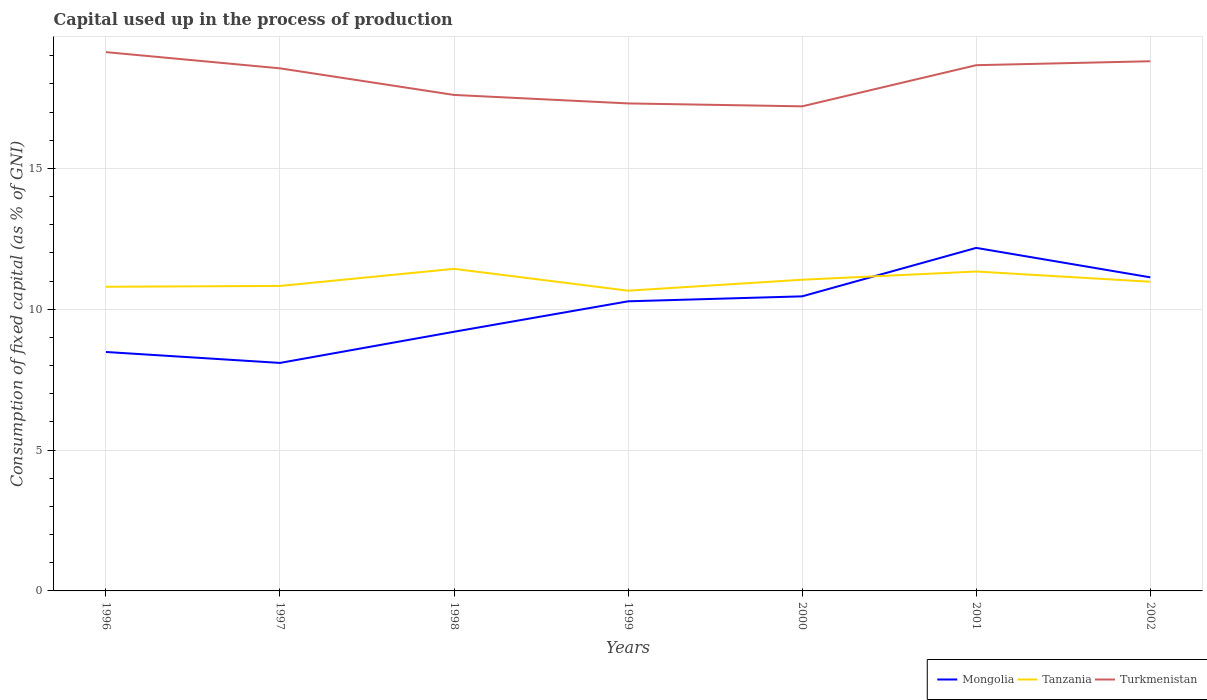How many different coloured lines are there?
Ensure brevity in your answer.  3. Is the number of lines equal to the number of legend labels?
Offer a very short reply. Yes. Across all years, what is the maximum capital used up in the process of production in Turkmenistan?
Offer a very short reply. 17.2. In which year was the capital used up in the process of production in Tanzania maximum?
Offer a very short reply. 1999. What is the total capital used up in the process of production in Mongolia in the graph?
Ensure brevity in your answer.  -1.9. What is the difference between the highest and the second highest capital used up in the process of production in Turkmenistan?
Make the answer very short. 1.92. What is the difference between the highest and the lowest capital used up in the process of production in Tanzania?
Your response must be concise. 3. Is the capital used up in the process of production in Mongolia strictly greater than the capital used up in the process of production in Turkmenistan over the years?
Give a very brief answer. Yes. How many years are there in the graph?
Give a very brief answer. 7. Does the graph contain any zero values?
Your answer should be compact. No. Does the graph contain grids?
Make the answer very short. Yes. How are the legend labels stacked?
Make the answer very short. Horizontal. What is the title of the graph?
Your answer should be very brief. Capital used up in the process of production. Does "Lithuania" appear as one of the legend labels in the graph?
Give a very brief answer. No. What is the label or title of the Y-axis?
Offer a terse response. Consumption of fixed capital (as % of GNI). What is the Consumption of fixed capital (as % of GNI) of Mongolia in 1996?
Your answer should be very brief. 8.48. What is the Consumption of fixed capital (as % of GNI) in Tanzania in 1996?
Make the answer very short. 10.8. What is the Consumption of fixed capital (as % of GNI) in Turkmenistan in 1996?
Your response must be concise. 19.13. What is the Consumption of fixed capital (as % of GNI) of Mongolia in 1997?
Keep it short and to the point. 8.09. What is the Consumption of fixed capital (as % of GNI) in Tanzania in 1997?
Keep it short and to the point. 10.83. What is the Consumption of fixed capital (as % of GNI) in Turkmenistan in 1997?
Offer a terse response. 18.55. What is the Consumption of fixed capital (as % of GNI) in Mongolia in 1998?
Provide a short and direct response. 9.2. What is the Consumption of fixed capital (as % of GNI) in Tanzania in 1998?
Make the answer very short. 11.43. What is the Consumption of fixed capital (as % of GNI) in Turkmenistan in 1998?
Offer a terse response. 17.61. What is the Consumption of fixed capital (as % of GNI) in Mongolia in 1999?
Ensure brevity in your answer.  10.28. What is the Consumption of fixed capital (as % of GNI) in Tanzania in 1999?
Offer a very short reply. 10.66. What is the Consumption of fixed capital (as % of GNI) of Turkmenistan in 1999?
Your answer should be very brief. 17.31. What is the Consumption of fixed capital (as % of GNI) in Mongolia in 2000?
Your answer should be compact. 10.46. What is the Consumption of fixed capital (as % of GNI) in Tanzania in 2000?
Provide a succinct answer. 11.05. What is the Consumption of fixed capital (as % of GNI) in Turkmenistan in 2000?
Offer a terse response. 17.2. What is the Consumption of fixed capital (as % of GNI) in Mongolia in 2001?
Your answer should be compact. 12.18. What is the Consumption of fixed capital (as % of GNI) of Tanzania in 2001?
Ensure brevity in your answer.  11.34. What is the Consumption of fixed capital (as % of GNI) in Turkmenistan in 2001?
Your response must be concise. 18.66. What is the Consumption of fixed capital (as % of GNI) of Mongolia in 2002?
Provide a succinct answer. 11.13. What is the Consumption of fixed capital (as % of GNI) in Tanzania in 2002?
Your answer should be very brief. 10.98. What is the Consumption of fixed capital (as % of GNI) of Turkmenistan in 2002?
Provide a succinct answer. 18.8. Across all years, what is the maximum Consumption of fixed capital (as % of GNI) of Mongolia?
Your answer should be very brief. 12.18. Across all years, what is the maximum Consumption of fixed capital (as % of GNI) of Tanzania?
Provide a short and direct response. 11.43. Across all years, what is the maximum Consumption of fixed capital (as % of GNI) in Turkmenistan?
Keep it short and to the point. 19.13. Across all years, what is the minimum Consumption of fixed capital (as % of GNI) in Mongolia?
Your answer should be compact. 8.09. Across all years, what is the minimum Consumption of fixed capital (as % of GNI) of Tanzania?
Your answer should be very brief. 10.66. Across all years, what is the minimum Consumption of fixed capital (as % of GNI) of Turkmenistan?
Provide a short and direct response. 17.2. What is the total Consumption of fixed capital (as % of GNI) in Mongolia in the graph?
Provide a succinct answer. 69.83. What is the total Consumption of fixed capital (as % of GNI) of Tanzania in the graph?
Give a very brief answer. 77.08. What is the total Consumption of fixed capital (as % of GNI) in Turkmenistan in the graph?
Your response must be concise. 127.26. What is the difference between the Consumption of fixed capital (as % of GNI) in Mongolia in 1996 and that in 1997?
Offer a terse response. 0.39. What is the difference between the Consumption of fixed capital (as % of GNI) in Tanzania in 1996 and that in 1997?
Your answer should be very brief. -0.03. What is the difference between the Consumption of fixed capital (as % of GNI) in Turkmenistan in 1996 and that in 1997?
Your answer should be very brief. 0.58. What is the difference between the Consumption of fixed capital (as % of GNI) of Mongolia in 1996 and that in 1998?
Offer a terse response. -0.72. What is the difference between the Consumption of fixed capital (as % of GNI) in Tanzania in 1996 and that in 1998?
Offer a terse response. -0.64. What is the difference between the Consumption of fixed capital (as % of GNI) in Turkmenistan in 1996 and that in 1998?
Give a very brief answer. 1.52. What is the difference between the Consumption of fixed capital (as % of GNI) of Mongolia in 1996 and that in 1999?
Offer a very short reply. -1.8. What is the difference between the Consumption of fixed capital (as % of GNI) in Tanzania in 1996 and that in 1999?
Provide a short and direct response. 0.14. What is the difference between the Consumption of fixed capital (as % of GNI) of Turkmenistan in 1996 and that in 1999?
Offer a very short reply. 1.82. What is the difference between the Consumption of fixed capital (as % of GNI) in Mongolia in 1996 and that in 2000?
Provide a succinct answer. -1.98. What is the difference between the Consumption of fixed capital (as % of GNI) in Tanzania in 1996 and that in 2000?
Your answer should be very brief. -0.25. What is the difference between the Consumption of fixed capital (as % of GNI) of Turkmenistan in 1996 and that in 2000?
Make the answer very short. 1.92. What is the difference between the Consumption of fixed capital (as % of GNI) of Mongolia in 1996 and that in 2001?
Make the answer very short. -3.7. What is the difference between the Consumption of fixed capital (as % of GNI) in Tanzania in 1996 and that in 2001?
Keep it short and to the point. -0.54. What is the difference between the Consumption of fixed capital (as % of GNI) in Turkmenistan in 1996 and that in 2001?
Provide a succinct answer. 0.46. What is the difference between the Consumption of fixed capital (as % of GNI) of Mongolia in 1996 and that in 2002?
Provide a succinct answer. -2.65. What is the difference between the Consumption of fixed capital (as % of GNI) in Tanzania in 1996 and that in 2002?
Make the answer very short. -0.18. What is the difference between the Consumption of fixed capital (as % of GNI) in Turkmenistan in 1996 and that in 2002?
Keep it short and to the point. 0.32. What is the difference between the Consumption of fixed capital (as % of GNI) in Mongolia in 1997 and that in 1998?
Keep it short and to the point. -1.11. What is the difference between the Consumption of fixed capital (as % of GNI) in Tanzania in 1997 and that in 1998?
Keep it short and to the point. -0.61. What is the difference between the Consumption of fixed capital (as % of GNI) of Turkmenistan in 1997 and that in 1998?
Offer a very short reply. 0.94. What is the difference between the Consumption of fixed capital (as % of GNI) of Mongolia in 1997 and that in 1999?
Provide a short and direct response. -2.19. What is the difference between the Consumption of fixed capital (as % of GNI) of Tanzania in 1997 and that in 1999?
Give a very brief answer. 0.17. What is the difference between the Consumption of fixed capital (as % of GNI) of Turkmenistan in 1997 and that in 1999?
Your answer should be very brief. 1.25. What is the difference between the Consumption of fixed capital (as % of GNI) of Mongolia in 1997 and that in 2000?
Make the answer very short. -2.36. What is the difference between the Consumption of fixed capital (as % of GNI) of Tanzania in 1997 and that in 2000?
Provide a short and direct response. -0.22. What is the difference between the Consumption of fixed capital (as % of GNI) in Turkmenistan in 1997 and that in 2000?
Your response must be concise. 1.35. What is the difference between the Consumption of fixed capital (as % of GNI) of Mongolia in 1997 and that in 2001?
Ensure brevity in your answer.  -4.08. What is the difference between the Consumption of fixed capital (as % of GNI) in Tanzania in 1997 and that in 2001?
Ensure brevity in your answer.  -0.51. What is the difference between the Consumption of fixed capital (as % of GNI) of Turkmenistan in 1997 and that in 2001?
Your response must be concise. -0.11. What is the difference between the Consumption of fixed capital (as % of GNI) of Mongolia in 1997 and that in 2002?
Give a very brief answer. -3.04. What is the difference between the Consumption of fixed capital (as % of GNI) of Tanzania in 1997 and that in 2002?
Offer a very short reply. -0.15. What is the difference between the Consumption of fixed capital (as % of GNI) in Turkmenistan in 1997 and that in 2002?
Keep it short and to the point. -0.25. What is the difference between the Consumption of fixed capital (as % of GNI) in Mongolia in 1998 and that in 1999?
Make the answer very short. -1.08. What is the difference between the Consumption of fixed capital (as % of GNI) of Tanzania in 1998 and that in 1999?
Provide a short and direct response. 0.78. What is the difference between the Consumption of fixed capital (as % of GNI) of Turkmenistan in 1998 and that in 1999?
Provide a succinct answer. 0.3. What is the difference between the Consumption of fixed capital (as % of GNI) of Mongolia in 1998 and that in 2000?
Your answer should be compact. -1.26. What is the difference between the Consumption of fixed capital (as % of GNI) of Tanzania in 1998 and that in 2000?
Your answer should be very brief. 0.39. What is the difference between the Consumption of fixed capital (as % of GNI) in Turkmenistan in 1998 and that in 2000?
Provide a succinct answer. 0.4. What is the difference between the Consumption of fixed capital (as % of GNI) of Mongolia in 1998 and that in 2001?
Ensure brevity in your answer.  -2.98. What is the difference between the Consumption of fixed capital (as % of GNI) of Tanzania in 1998 and that in 2001?
Ensure brevity in your answer.  0.1. What is the difference between the Consumption of fixed capital (as % of GNI) in Turkmenistan in 1998 and that in 2001?
Offer a terse response. -1.06. What is the difference between the Consumption of fixed capital (as % of GNI) of Mongolia in 1998 and that in 2002?
Keep it short and to the point. -1.93. What is the difference between the Consumption of fixed capital (as % of GNI) of Tanzania in 1998 and that in 2002?
Your response must be concise. 0.46. What is the difference between the Consumption of fixed capital (as % of GNI) in Turkmenistan in 1998 and that in 2002?
Provide a short and direct response. -1.2. What is the difference between the Consumption of fixed capital (as % of GNI) of Mongolia in 1999 and that in 2000?
Provide a short and direct response. -0.18. What is the difference between the Consumption of fixed capital (as % of GNI) in Tanzania in 1999 and that in 2000?
Offer a very short reply. -0.39. What is the difference between the Consumption of fixed capital (as % of GNI) in Turkmenistan in 1999 and that in 2000?
Your answer should be very brief. 0.1. What is the difference between the Consumption of fixed capital (as % of GNI) of Mongolia in 1999 and that in 2001?
Your response must be concise. -1.9. What is the difference between the Consumption of fixed capital (as % of GNI) in Tanzania in 1999 and that in 2001?
Give a very brief answer. -0.68. What is the difference between the Consumption of fixed capital (as % of GNI) in Turkmenistan in 1999 and that in 2001?
Your answer should be very brief. -1.36. What is the difference between the Consumption of fixed capital (as % of GNI) of Mongolia in 1999 and that in 2002?
Make the answer very short. -0.85. What is the difference between the Consumption of fixed capital (as % of GNI) of Tanzania in 1999 and that in 2002?
Keep it short and to the point. -0.32. What is the difference between the Consumption of fixed capital (as % of GNI) in Turkmenistan in 1999 and that in 2002?
Give a very brief answer. -1.5. What is the difference between the Consumption of fixed capital (as % of GNI) in Mongolia in 2000 and that in 2001?
Offer a terse response. -1.72. What is the difference between the Consumption of fixed capital (as % of GNI) in Tanzania in 2000 and that in 2001?
Keep it short and to the point. -0.29. What is the difference between the Consumption of fixed capital (as % of GNI) of Turkmenistan in 2000 and that in 2001?
Your response must be concise. -1.46. What is the difference between the Consumption of fixed capital (as % of GNI) in Mongolia in 2000 and that in 2002?
Provide a short and direct response. -0.68. What is the difference between the Consumption of fixed capital (as % of GNI) of Tanzania in 2000 and that in 2002?
Offer a very short reply. 0.07. What is the difference between the Consumption of fixed capital (as % of GNI) in Turkmenistan in 2000 and that in 2002?
Provide a short and direct response. -1.6. What is the difference between the Consumption of fixed capital (as % of GNI) of Mongolia in 2001 and that in 2002?
Make the answer very short. 1.04. What is the difference between the Consumption of fixed capital (as % of GNI) in Tanzania in 2001 and that in 2002?
Give a very brief answer. 0.36. What is the difference between the Consumption of fixed capital (as % of GNI) of Turkmenistan in 2001 and that in 2002?
Provide a succinct answer. -0.14. What is the difference between the Consumption of fixed capital (as % of GNI) of Mongolia in 1996 and the Consumption of fixed capital (as % of GNI) of Tanzania in 1997?
Give a very brief answer. -2.34. What is the difference between the Consumption of fixed capital (as % of GNI) in Mongolia in 1996 and the Consumption of fixed capital (as % of GNI) in Turkmenistan in 1997?
Provide a short and direct response. -10.07. What is the difference between the Consumption of fixed capital (as % of GNI) in Tanzania in 1996 and the Consumption of fixed capital (as % of GNI) in Turkmenistan in 1997?
Offer a terse response. -7.75. What is the difference between the Consumption of fixed capital (as % of GNI) of Mongolia in 1996 and the Consumption of fixed capital (as % of GNI) of Tanzania in 1998?
Your response must be concise. -2.95. What is the difference between the Consumption of fixed capital (as % of GNI) of Mongolia in 1996 and the Consumption of fixed capital (as % of GNI) of Turkmenistan in 1998?
Offer a terse response. -9.13. What is the difference between the Consumption of fixed capital (as % of GNI) of Tanzania in 1996 and the Consumption of fixed capital (as % of GNI) of Turkmenistan in 1998?
Offer a very short reply. -6.81. What is the difference between the Consumption of fixed capital (as % of GNI) in Mongolia in 1996 and the Consumption of fixed capital (as % of GNI) in Tanzania in 1999?
Provide a succinct answer. -2.18. What is the difference between the Consumption of fixed capital (as % of GNI) of Mongolia in 1996 and the Consumption of fixed capital (as % of GNI) of Turkmenistan in 1999?
Offer a very short reply. -8.82. What is the difference between the Consumption of fixed capital (as % of GNI) of Tanzania in 1996 and the Consumption of fixed capital (as % of GNI) of Turkmenistan in 1999?
Keep it short and to the point. -6.51. What is the difference between the Consumption of fixed capital (as % of GNI) of Mongolia in 1996 and the Consumption of fixed capital (as % of GNI) of Tanzania in 2000?
Offer a terse response. -2.56. What is the difference between the Consumption of fixed capital (as % of GNI) in Mongolia in 1996 and the Consumption of fixed capital (as % of GNI) in Turkmenistan in 2000?
Your answer should be compact. -8.72. What is the difference between the Consumption of fixed capital (as % of GNI) in Tanzania in 1996 and the Consumption of fixed capital (as % of GNI) in Turkmenistan in 2000?
Your response must be concise. -6.41. What is the difference between the Consumption of fixed capital (as % of GNI) in Mongolia in 1996 and the Consumption of fixed capital (as % of GNI) in Tanzania in 2001?
Provide a succinct answer. -2.86. What is the difference between the Consumption of fixed capital (as % of GNI) in Mongolia in 1996 and the Consumption of fixed capital (as % of GNI) in Turkmenistan in 2001?
Ensure brevity in your answer.  -10.18. What is the difference between the Consumption of fixed capital (as % of GNI) of Tanzania in 1996 and the Consumption of fixed capital (as % of GNI) of Turkmenistan in 2001?
Ensure brevity in your answer.  -7.87. What is the difference between the Consumption of fixed capital (as % of GNI) of Mongolia in 1996 and the Consumption of fixed capital (as % of GNI) of Tanzania in 2002?
Your response must be concise. -2.49. What is the difference between the Consumption of fixed capital (as % of GNI) in Mongolia in 1996 and the Consumption of fixed capital (as % of GNI) in Turkmenistan in 2002?
Keep it short and to the point. -10.32. What is the difference between the Consumption of fixed capital (as % of GNI) in Tanzania in 1996 and the Consumption of fixed capital (as % of GNI) in Turkmenistan in 2002?
Provide a short and direct response. -8.01. What is the difference between the Consumption of fixed capital (as % of GNI) in Mongolia in 1997 and the Consumption of fixed capital (as % of GNI) in Tanzania in 1998?
Ensure brevity in your answer.  -3.34. What is the difference between the Consumption of fixed capital (as % of GNI) of Mongolia in 1997 and the Consumption of fixed capital (as % of GNI) of Turkmenistan in 1998?
Provide a succinct answer. -9.51. What is the difference between the Consumption of fixed capital (as % of GNI) in Tanzania in 1997 and the Consumption of fixed capital (as % of GNI) in Turkmenistan in 1998?
Give a very brief answer. -6.78. What is the difference between the Consumption of fixed capital (as % of GNI) of Mongolia in 1997 and the Consumption of fixed capital (as % of GNI) of Tanzania in 1999?
Offer a terse response. -2.56. What is the difference between the Consumption of fixed capital (as % of GNI) in Mongolia in 1997 and the Consumption of fixed capital (as % of GNI) in Turkmenistan in 1999?
Make the answer very short. -9.21. What is the difference between the Consumption of fixed capital (as % of GNI) of Tanzania in 1997 and the Consumption of fixed capital (as % of GNI) of Turkmenistan in 1999?
Make the answer very short. -6.48. What is the difference between the Consumption of fixed capital (as % of GNI) of Mongolia in 1997 and the Consumption of fixed capital (as % of GNI) of Tanzania in 2000?
Give a very brief answer. -2.95. What is the difference between the Consumption of fixed capital (as % of GNI) of Mongolia in 1997 and the Consumption of fixed capital (as % of GNI) of Turkmenistan in 2000?
Provide a succinct answer. -9.11. What is the difference between the Consumption of fixed capital (as % of GNI) of Tanzania in 1997 and the Consumption of fixed capital (as % of GNI) of Turkmenistan in 2000?
Give a very brief answer. -6.38. What is the difference between the Consumption of fixed capital (as % of GNI) of Mongolia in 1997 and the Consumption of fixed capital (as % of GNI) of Tanzania in 2001?
Your answer should be compact. -3.25. What is the difference between the Consumption of fixed capital (as % of GNI) in Mongolia in 1997 and the Consumption of fixed capital (as % of GNI) in Turkmenistan in 2001?
Offer a terse response. -10.57. What is the difference between the Consumption of fixed capital (as % of GNI) in Tanzania in 1997 and the Consumption of fixed capital (as % of GNI) in Turkmenistan in 2001?
Your response must be concise. -7.84. What is the difference between the Consumption of fixed capital (as % of GNI) of Mongolia in 1997 and the Consumption of fixed capital (as % of GNI) of Tanzania in 2002?
Make the answer very short. -2.88. What is the difference between the Consumption of fixed capital (as % of GNI) in Mongolia in 1997 and the Consumption of fixed capital (as % of GNI) in Turkmenistan in 2002?
Offer a very short reply. -10.71. What is the difference between the Consumption of fixed capital (as % of GNI) of Tanzania in 1997 and the Consumption of fixed capital (as % of GNI) of Turkmenistan in 2002?
Provide a short and direct response. -7.98. What is the difference between the Consumption of fixed capital (as % of GNI) of Mongolia in 1998 and the Consumption of fixed capital (as % of GNI) of Tanzania in 1999?
Offer a terse response. -1.46. What is the difference between the Consumption of fixed capital (as % of GNI) in Mongolia in 1998 and the Consumption of fixed capital (as % of GNI) in Turkmenistan in 1999?
Give a very brief answer. -8.11. What is the difference between the Consumption of fixed capital (as % of GNI) in Tanzania in 1998 and the Consumption of fixed capital (as % of GNI) in Turkmenistan in 1999?
Offer a very short reply. -5.87. What is the difference between the Consumption of fixed capital (as % of GNI) in Mongolia in 1998 and the Consumption of fixed capital (as % of GNI) in Tanzania in 2000?
Your answer should be compact. -1.85. What is the difference between the Consumption of fixed capital (as % of GNI) of Mongolia in 1998 and the Consumption of fixed capital (as % of GNI) of Turkmenistan in 2000?
Your answer should be very brief. -8. What is the difference between the Consumption of fixed capital (as % of GNI) in Tanzania in 1998 and the Consumption of fixed capital (as % of GNI) in Turkmenistan in 2000?
Your answer should be compact. -5.77. What is the difference between the Consumption of fixed capital (as % of GNI) in Mongolia in 1998 and the Consumption of fixed capital (as % of GNI) in Tanzania in 2001?
Your answer should be compact. -2.14. What is the difference between the Consumption of fixed capital (as % of GNI) in Mongolia in 1998 and the Consumption of fixed capital (as % of GNI) in Turkmenistan in 2001?
Provide a succinct answer. -9.46. What is the difference between the Consumption of fixed capital (as % of GNI) in Tanzania in 1998 and the Consumption of fixed capital (as % of GNI) in Turkmenistan in 2001?
Your answer should be compact. -7.23. What is the difference between the Consumption of fixed capital (as % of GNI) in Mongolia in 1998 and the Consumption of fixed capital (as % of GNI) in Tanzania in 2002?
Your response must be concise. -1.77. What is the difference between the Consumption of fixed capital (as % of GNI) of Mongolia in 1998 and the Consumption of fixed capital (as % of GNI) of Turkmenistan in 2002?
Give a very brief answer. -9.6. What is the difference between the Consumption of fixed capital (as % of GNI) of Tanzania in 1998 and the Consumption of fixed capital (as % of GNI) of Turkmenistan in 2002?
Provide a succinct answer. -7.37. What is the difference between the Consumption of fixed capital (as % of GNI) of Mongolia in 1999 and the Consumption of fixed capital (as % of GNI) of Tanzania in 2000?
Offer a very short reply. -0.77. What is the difference between the Consumption of fixed capital (as % of GNI) of Mongolia in 1999 and the Consumption of fixed capital (as % of GNI) of Turkmenistan in 2000?
Give a very brief answer. -6.92. What is the difference between the Consumption of fixed capital (as % of GNI) of Tanzania in 1999 and the Consumption of fixed capital (as % of GNI) of Turkmenistan in 2000?
Provide a short and direct response. -6.54. What is the difference between the Consumption of fixed capital (as % of GNI) of Mongolia in 1999 and the Consumption of fixed capital (as % of GNI) of Tanzania in 2001?
Offer a terse response. -1.06. What is the difference between the Consumption of fixed capital (as % of GNI) in Mongolia in 1999 and the Consumption of fixed capital (as % of GNI) in Turkmenistan in 2001?
Provide a short and direct response. -8.38. What is the difference between the Consumption of fixed capital (as % of GNI) of Tanzania in 1999 and the Consumption of fixed capital (as % of GNI) of Turkmenistan in 2001?
Provide a short and direct response. -8. What is the difference between the Consumption of fixed capital (as % of GNI) of Mongolia in 1999 and the Consumption of fixed capital (as % of GNI) of Tanzania in 2002?
Keep it short and to the point. -0.69. What is the difference between the Consumption of fixed capital (as % of GNI) in Mongolia in 1999 and the Consumption of fixed capital (as % of GNI) in Turkmenistan in 2002?
Offer a terse response. -8.52. What is the difference between the Consumption of fixed capital (as % of GNI) of Tanzania in 1999 and the Consumption of fixed capital (as % of GNI) of Turkmenistan in 2002?
Make the answer very short. -8.14. What is the difference between the Consumption of fixed capital (as % of GNI) of Mongolia in 2000 and the Consumption of fixed capital (as % of GNI) of Tanzania in 2001?
Your answer should be very brief. -0.88. What is the difference between the Consumption of fixed capital (as % of GNI) of Mongolia in 2000 and the Consumption of fixed capital (as % of GNI) of Turkmenistan in 2001?
Your response must be concise. -8.21. What is the difference between the Consumption of fixed capital (as % of GNI) in Tanzania in 2000 and the Consumption of fixed capital (as % of GNI) in Turkmenistan in 2001?
Provide a short and direct response. -7.62. What is the difference between the Consumption of fixed capital (as % of GNI) in Mongolia in 2000 and the Consumption of fixed capital (as % of GNI) in Tanzania in 2002?
Your answer should be very brief. -0.52. What is the difference between the Consumption of fixed capital (as % of GNI) in Mongolia in 2000 and the Consumption of fixed capital (as % of GNI) in Turkmenistan in 2002?
Ensure brevity in your answer.  -8.35. What is the difference between the Consumption of fixed capital (as % of GNI) of Tanzania in 2000 and the Consumption of fixed capital (as % of GNI) of Turkmenistan in 2002?
Provide a short and direct response. -7.76. What is the difference between the Consumption of fixed capital (as % of GNI) in Mongolia in 2001 and the Consumption of fixed capital (as % of GNI) in Tanzania in 2002?
Your answer should be very brief. 1.2. What is the difference between the Consumption of fixed capital (as % of GNI) of Mongolia in 2001 and the Consumption of fixed capital (as % of GNI) of Turkmenistan in 2002?
Provide a short and direct response. -6.63. What is the difference between the Consumption of fixed capital (as % of GNI) of Tanzania in 2001 and the Consumption of fixed capital (as % of GNI) of Turkmenistan in 2002?
Ensure brevity in your answer.  -7.46. What is the average Consumption of fixed capital (as % of GNI) of Mongolia per year?
Offer a very short reply. 9.98. What is the average Consumption of fixed capital (as % of GNI) in Tanzania per year?
Provide a short and direct response. 11.01. What is the average Consumption of fixed capital (as % of GNI) in Turkmenistan per year?
Your response must be concise. 18.18. In the year 1996, what is the difference between the Consumption of fixed capital (as % of GNI) of Mongolia and Consumption of fixed capital (as % of GNI) of Tanzania?
Your response must be concise. -2.32. In the year 1996, what is the difference between the Consumption of fixed capital (as % of GNI) of Mongolia and Consumption of fixed capital (as % of GNI) of Turkmenistan?
Provide a succinct answer. -10.65. In the year 1996, what is the difference between the Consumption of fixed capital (as % of GNI) in Tanzania and Consumption of fixed capital (as % of GNI) in Turkmenistan?
Your answer should be compact. -8.33. In the year 1997, what is the difference between the Consumption of fixed capital (as % of GNI) of Mongolia and Consumption of fixed capital (as % of GNI) of Tanzania?
Your response must be concise. -2.73. In the year 1997, what is the difference between the Consumption of fixed capital (as % of GNI) of Mongolia and Consumption of fixed capital (as % of GNI) of Turkmenistan?
Keep it short and to the point. -10.46. In the year 1997, what is the difference between the Consumption of fixed capital (as % of GNI) in Tanzania and Consumption of fixed capital (as % of GNI) in Turkmenistan?
Offer a very short reply. -7.72. In the year 1998, what is the difference between the Consumption of fixed capital (as % of GNI) of Mongolia and Consumption of fixed capital (as % of GNI) of Tanzania?
Ensure brevity in your answer.  -2.23. In the year 1998, what is the difference between the Consumption of fixed capital (as % of GNI) of Mongolia and Consumption of fixed capital (as % of GNI) of Turkmenistan?
Give a very brief answer. -8.41. In the year 1998, what is the difference between the Consumption of fixed capital (as % of GNI) of Tanzania and Consumption of fixed capital (as % of GNI) of Turkmenistan?
Your answer should be compact. -6.17. In the year 1999, what is the difference between the Consumption of fixed capital (as % of GNI) in Mongolia and Consumption of fixed capital (as % of GNI) in Tanzania?
Keep it short and to the point. -0.38. In the year 1999, what is the difference between the Consumption of fixed capital (as % of GNI) in Mongolia and Consumption of fixed capital (as % of GNI) in Turkmenistan?
Your answer should be very brief. -7.03. In the year 1999, what is the difference between the Consumption of fixed capital (as % of GNI) in Tanzania and Consumption of fixed capital (as % of GNI) in Turkmenistan?
Provide a succinct answer. -6.65. In the year 2000, what is the difference between the Consumption of fixed capital (as % of GNI) in Mongolia and Consumption of fixed capital (as % of GNI) in Tanzania?
Keep it short and to the point. -0.59. In the year 2000, what is the difference between the Consumption of fixed capital (as % of GNI) of Mongolia and Consumption of fixed capital (as % of GNI) of Turkmenistan?
Offer a terse response. -6.75. In the year 2000, what is the difference between the Consumption of fixed capital (as % of GNI) of Tanzania and Consumption of fixed capital (as % of GNI) of Turkmenistan?
Give a very brief answer. -6.16. In the year 2001, what is the difference between the Consumption of fixed capital (as % of GNI) of Mongolia and Consumption of fixed capital (as % of GNI) of Tanzania?
Your response must be concise. 0.84. In the year 2001, what is the difference between the Consumption of fixed capital (as % of GNI) of Mongolia and Consumption of fixed capital (as % of GNI) of Turkmenistan?
Ensure brevity in your answer.  -6.49. In the year 2001, what is the difference between the Consumption of fixed capital (as % of GNI) of Tanzania and Consumption of fixed capital (as % of GNI) of Turkmenistan?
Keep it short and to the point. -7.32. In the year 2002, what is the difference between the Consumption of fixed capital (as % of GNI) of Mongolia and Consumption of fixed capital (as % of GNI) of Tanzania?
Provide a short and direct response. 0.16. In the year 2002, what is the difference between the Consumption of fixed capital (as % of GNI) in Mongolia and Consumption of fixed capital (as % of GNI) in Turkmenistan?
Give a very brief answer. -7.67. In the year 2002, what is the difference between the Consumption of fixed capital (as % of GNI) in Tanzania and Consumption of fixed capital (as % of GNI) in Turkmenistan?
Your answer should be very brief. -7.83. What is the ratio of the Consumption of fixed capital (as % of GNI) of Mongolia in 1996 to that in 1997?
Your answer should be very brief. 1.05. What is the ratio of the Consumption of fixed capital (as % of GNI) of Turkmenistan in 1996 to that in 1997?
Offer a terse response. 1.03. What is the ratio of the Consumption of fixed capital (as % of GNI) in Mongolia in 1996 to that in 1998?
Keep it short and to the point. 0.92. What is the ratio of the Consumption of fixed capital (as % of GNI) in Tanzania in 1996 to that in 1998?
Offer a very short reply. 0.94. What is the ratio of the Consumption of fixed capital (as % of GNI) of Turkmenistan in 1996 to that in 1998?
Give a very brief answer. 1.09. What is the ratio of the Consumption of fixed capital (as % of GNI) in Mongolia in 1996 to that in 1999?
Your answer should be compact. 0.82. What is the ratio of the Consumption of fixed capital (as % of GNI) in Tanzania in 1996 to that in 1999?
Your answer should be very brief. 1.01. What is the ratio of the Consumption of fixed capital (as % of GNI) of Turkmenistan in 1996 to that in 1999?
Your answer should be compact. 1.11. What is the ratio of the Consumption of fixed capital (as % of GNI) of Mongolia in 1996 to that in 2000?
Provide a short and direct response. 0.81. What is the ratio of the Consumption of fixed capital (as % of GNI) in Tanzania in 1996 to that in 2000?
Your answer should be compact. 0.98. What is the ratio of the Consumption of fixed capital (as % of GNI) in Turkmenistan in 1996 to that in 2000?
Offer a terse response. 1.11. What is the ratio of the Consumption of fixed capital (as % of GNI) of Mongolia in 1996 to that in 2001?
Keep it short and to the point. 0.7. What is the ratio of the Consumption of fixed capital (as % of GNI) of Tanzania in 1996 to that in 2001?
Provide a short and direct response. 0.95. What is the ratio of the Consumption of fixed capital (as % of GNI) in Turkmenistan in 1996 to that in 2001?
Your response must be concise. 1.02. What is the ratio of the Consumption of fixed capital (as % of GNI) in Mongolia in 1996 to that in 2002?
Offer a very short reply. 0.76. What is the ratio of the Consumption of fixed capital (as % of GNI) of Tanzania in 1996 to that in 2002?
Keep it short and to the point. 0.98. What is the ratio of the Consumption of fixed capital (as % of GNI) of Turkmenistan in 1996 to that in 2002?
Keep it short and to the point. 1.02. What is the ratio of the Consumption of fixed capital (as % of GNI) of Mongolia in 1997 to that in 1998?
Your response must be concise. 0.88. What is the ratio of the Consumption of fixed capital (as % of GNI) in Tanzania in 1997 to that in 1998?
Provide a short and direct response. 0.95. What is the ratio of the Consumption of fixed capital (as % of GNI) of Turkmenistan in 1997 to that in 1998?
Keep it short and to the point. 1.05. What is the ratio of the Consumption of fixed capital (as % of GNI) of Mongolia in 1997 to that in 1999?
Your response must be concise. 0.79. What is the ratio of the Consumption of fixed capital (as % of GNI) in Tanzania in 1997 to that in 1999?
Ensure brevity in your answer.  1.02. What is the ratio of the Consumption of fixed capital (as % of GNI) in Turkmenistan in 1997 to that in 1999?
Your answer should be very brief. 1.07. What is the ratio of the Consumption of fixed capital (as % of GNI) of Mongolia in 1997 to that in 2000?
Offer a very short reply. 0.77. What is the ratio of the Consumption of fixed capital (as % of GNI) of Tanzania in 1997 to that in 2000?
Provide a short and direct response. 0.98. What is the ratio of the Consumption of fixed capital (as % of GNI) in Turkmenistan in 1997 to that in 2000?
Offer a very short reply. 1.08. What is the ratio of the Consumption of fixed capital (as % of GNI) in Mongolia in 1997 to that in 2001?
Offer a very short reply. 0.66. What is the ratio of the Consumption of fixed capital (as % of GNI) of Tanzania in 1997 to that in 2001?
Your answer should be compact. 0.95. What is the ratio of the Consumption of fixed capital (as % of GNI) of Mongolia in 1997 to that in 2002?
Offer a very short reply. 0.73. What is the ratio of the Consumption of fixed capital (as % of GNI) in Tanzania in 1997 to that in 2002?
Your answer should be very brief. 0.99. What is the ratio of the Consumption of fixed capital (as % of GNI) of Turkmenistan in 1997 to that in 2002?
Give a very brief answer. 0.99. What is the ratio of the Consumption of fixed capital (as % of GNI) of Mongolia in 1998 to that in 1999?
Ensure brevity in your answer.  0.89. What is the ratio of the Consumption of fixed capital (as % of GNI) in Tanzania in 1998 to that in 1999?
Provide a short and direct response. 1.07. What is the ratio of the Consumption of fixed capital (as % of GNI) of Turkmenistan in 1998 to that in 1999?
Your response must be concise. 1.02. What is the ratio of the Consumption of fixed capital (as % of GNI) in Mongolia in 1998 to that in 2000?
Provide a short and direct response. 0.88. What is the ratio of the Consumption of fixed capital (as % of GNI) in Tanzania in 1998 to that in 2000?
Provide a succinct answer. 1.03. What is the ratio of the Consumption of fixed capital (as % of GNI) of Turkmenistan in 1998 to that in 2000?
Your answer should be very brief. 1.02. What is the ratio of the Consumption of fixed capital (as % of GNI) of Mongolia in 1998 to that in 2001?
Give a very brief answer. 0.76. What is the ratio of the Consumption of fixed capital (as % of GNI) in Tanzania in 1998 to that in 2001?
Give a very brief answer. 1.01. What is the ratio of the Consumption of fixed capital (as % of GNI) in Turkmenistan in 1998 to that in 2001?
Ensure brevity in your answer.  0.94. What is the ratio of the Consumption of fixed capital (as % of GNI) in Mongolia in 1998 to that in 2002?
Offer a very short reply. 0.83. What is the ratio of the Consumption of fixed capital (as % of GNI) of Tanzania in 1998 to that in 2002?
Keep it short and to the point. 1.04. What is the ratio of the Consumption of fixed capital (as % of GNI) in Turkmenistan in 1998 to that in 2002?
Offer a very short reply. 0.94. What is the ratio of the Consumption of fixed capital (as % of GNI) of Mongolia in 1999 to that in 2000?
Your answer should be very brief. 0.98. What is the ratio of the Consumption of fixed capital (as % of GNI) in Tanzania in 1999 to that in 2000?
Your answer should be very brief. 0.96. What is the ratio of the Consumption of fixed capital (as % of GNI) of Mongolia in 1999 to that in 2001?
Provide a short and direct response. 0.84. What is the ratio of the Consumption of fixed capital (as % of GNI) in Tanzania in 1999 to that in 2001?
Ensure brevity in your answer.  0.94. What is the ratio of the Consumption of fixed capital (as % of GNI) of Turkmenistan in 1999 to that in 2001?
Your response must be concise. 0.93. What is the ratio of the Consumption of fixed capital (as % of GNI) in Mongolia in 1999 to that in 2002?
Give a very brief answer. 0.92. What is the ratio of the Consumption of fixed capital (as % of GNI) in Tanzania in 1999 to that in 2002?
Provide a short and direct response. 0.97. What is the ratio of the Consumption of fixed capital (as % of GNI) of Turkmenistan in 1999 to that in 2002?
Keep it short and to the point. 0.92. What is the ratio of the Consumption of fixed capital (as % of GNI) of Mongolia in 2000 to that in 2001?
Ensure brevity in your answer.  0.86. What is the ratio of the Consumption of fixed capital (as % of GNI) in Tanzania in 2000 to that in 2001?
Keep it short and to the point. 0.97. What is the ratio of the Consumption of fixed capital (as % of GNI) of Turkmenistan in 2000 to that in 2001?
Offer a very short reply. 0.92. What is the ratio of the Consumption of fixed capital (as % of GNI) of Mongolia in 2000 to that in 2002?
Your response must be concise. 0.94. What is the ratio of the Consumption of fixed capital (as % of GNI) in Tanzania in 2000 to that in 2002?
Your answer should be very brief. 1.01. What is the ratio of the Consumption of fixed capital (as % of GNI) in Turkmenistan in 2000 to that in 2002?
Provide a short and direct response. 0.91. What is the ratio of the Consumption of fixed capital (as % of GNI) in Mongolia in 2001 to that in 2002?
Give a very brief answer. 1.09. What is the ratio of the Consumption of fixed capital (as % of GNI) in Tanzania in 2001 to that in 2002?
Your answer should be very brief. 1.03. What is the difference between the highest and the second highest Consumption of fixed capital (as % of GNI) of Mongolia?
Your answer should be compact. 1.04. What is the difference between the highest and the second highest Consumption of fixed capital (as % of GNI) in Tanzania?
Your answer should be compact. 0.1. What is the difference between the highest and the second highest Consumption of fixed capital (as % of GNI) of Turkmenistan?
Offer a terse response. 0.32. What is the difference between the highest and the lowest Consumption of fixed capital (as % of GNI) of Mongolia?
Offer a terse response. 4.08. What is the difference between the highest and the lowest Consumption of fixed capital (as % of GNI) of Tanzania?
Make the answer very short. 0.78. What is the difference between the highest and the lowest Consumption of fixed capital (as % of GNI) in Turkmenistan?
Your response must be concise. 1.92. 